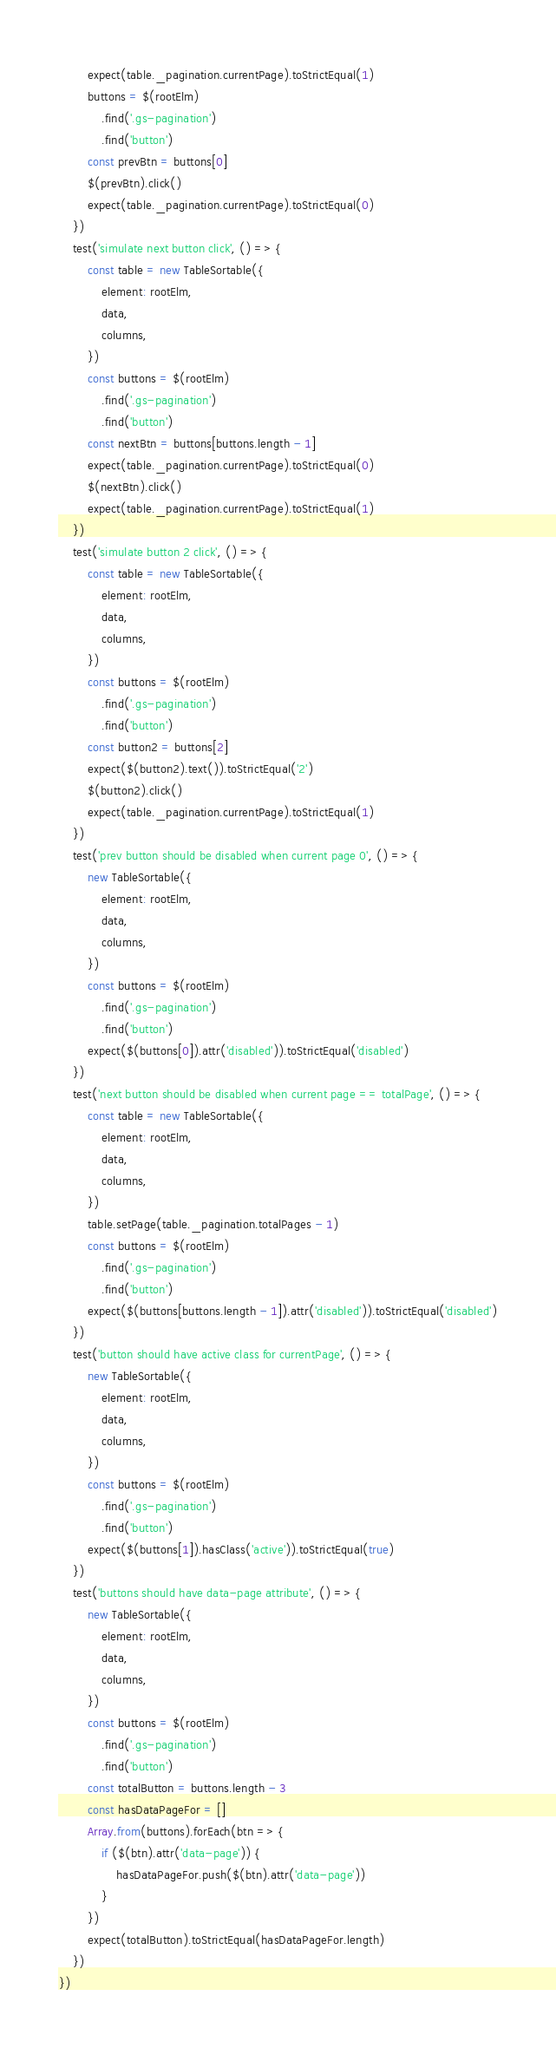<code> <loc_0><loc_0><loc_500><loc_500><_JavaScript_>        expect(table._pagination.currentPage).toStrictEqual(1)
        buttons = $(rootElm)
            .find('.gs-pagination')
            .find('button')
        const prevBtn = buttons[0]
        $(prevBtn).click()
        expect(table._pagination.currentPage).toStrictEqual(0)
    })
    test('simulate next button click', () => {
        const table = new TableSortable({
            element: rootElm,
            data,
            columns,
        })
        const buttons = $(rootElm)
            .find('.gs-pagination')
            .find('button')
        const nextBtn = buttons[buttons.length - 1]
        expect(table._pagination.currentPage).toStrictEqual(0)
        $(nextBtn).click()
        expect(table._pagination.currentPage).toStrictEqual(1)
    })
    test('simulate button 2 click', () => {
        const table = new TableSortable({
            element: rootElm,
            data,
            columns,
        })
        const buttons = $(rootElm)
            .find('.gs-pagination')
            .find('button')
        const button2 = buttons[2]
        expect($(button2).text()).toStrictEqual('2')
        $(button2).click()
        expect(table._pagination.currentPage).toStrictEqual(1)
    })
    test('prev button should be disabled when current page 0', () => {
        new TableSortable({
            element: rootElm,
            data,
            columns,
        })
        const buttons = $(rootElm)
            .find('.gs-pagination')
            .find('button')
        expect($(buttons[0]).attr('disabled')).toStrictEqual('disabled')
    })
    test('next button should be disabled when current page == totalPage', () => {
        const table = new TableSortable({
            element: rootElm,
            data,
            columns,
        })
        table.setPage(table._pagination.totalPages - 1)
        const buttons = $(rootElm)
            .find('.gs-pagination')
            .find('button')
        expect($(buttons[buttons.length - 1]).attr('disabled')).toStrictEqual('disabled')
    })
    test('button should have active class for currentPage', () => {
        new TableSortable({
            element: rootElm,
            data,
            columns,
        })
        const buttons = $(rootElm)
            .find('.gs-pagination')
            .find('button')
        expect($(buttons[1]).hasClass('active')).toStrictEqual(true)
    })
    test('buttons should have data-page attribute', () => {
        new TableSortable({
            element: rootElm,
            data,
            columns,
        })
        const buttons = $(rootElm)
            .find('.gs-pagination')
            .find('button')
        const totalButton = buttons.length - 3
        const hasDataPageFor = []
        Array.from(buttons).forEach(btn => {
            if ($(btn).attr('data-page')) {
                hasDataPageFor.push($(btn).attr('data-page'))
            }
        })
        expect(totalButton).toStrictEqual(hasDataPageFor.length)
    })
})
</code> 